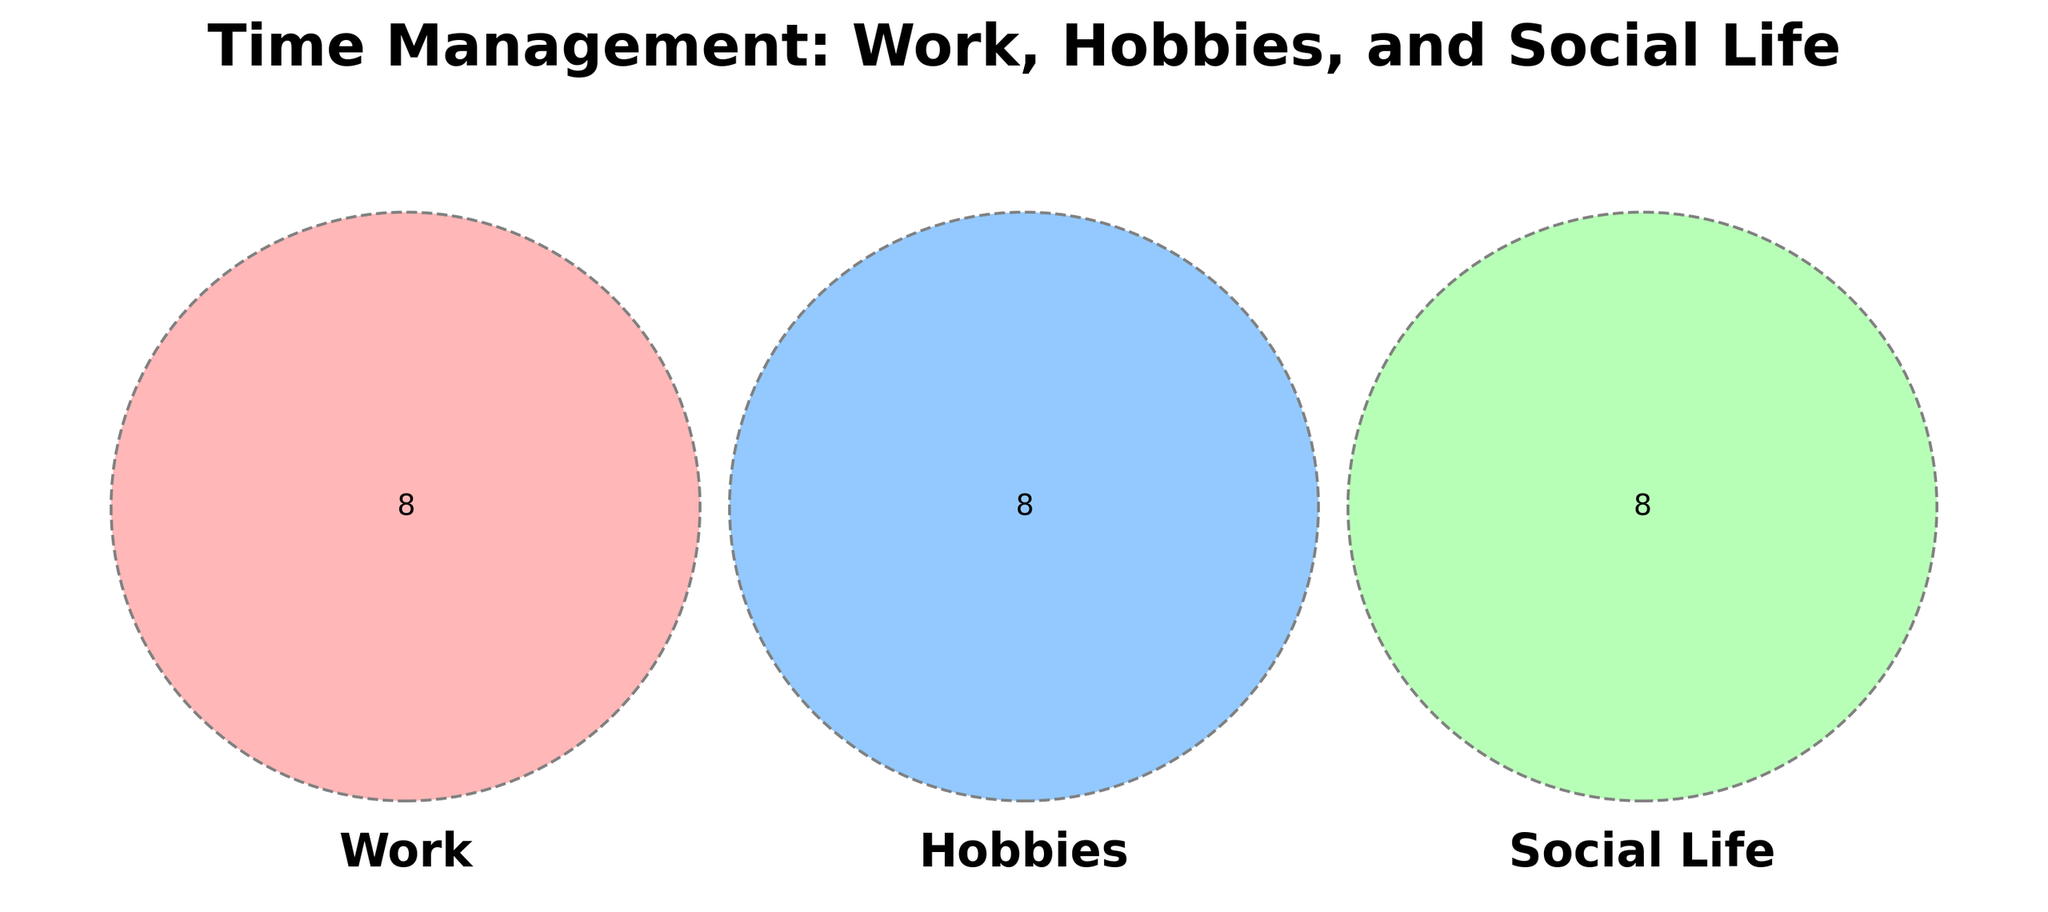What activities fall into the shared area of Work, Hobbies, and Social Life? The shared area in the Venn diagram represents activities common to all three categories. Observe the intersection of all sets.
Answer: None What is the title of the Venn diagram? The title is usually found at the top of the figure. Read it directly from there.
Answer: Time Management: Work, Hobbies, and Social Life Which activities are unique to Hobbies? The unique subset of Hobbies is the part that doesn't overlap with Work or Social Life. Check the section labeled "Hobbies" without any intersections.
Answer: Yarn shopping, Pattern reading, Scarf projects, Craft fairs, Online tutorials, Knitting blogs, Stitch practice How many activities are shared between Work and Social Life but not Hobbies? Look at the intersection between Work and Social Life circles, excluding the area also intersecting with Hobbies.
Answer: 0 Are there more activities in the Hobbies-only section or Social Life-only section? Compare the number of items exclusive to Hobbies and those exclusive to Social Life by counting them in the corresponding areas.
Answer: Hobbies-only Which section has the fewest items? Count the activities in each different section of the diagram to determine which has the least.
Answer: Social Life What combination of activities might involve "Reports" and "Knitting classes"? Find the intersection where "Reports" (Work) and "Knitting classes" (Hobbies) could overlap, excluding the Social Life section.
Answer: None Do Work and Hobbies share any activities? Check the area where the Work and Hobbies circles intersect but exclude the Social Life intersection.
Answer: None 